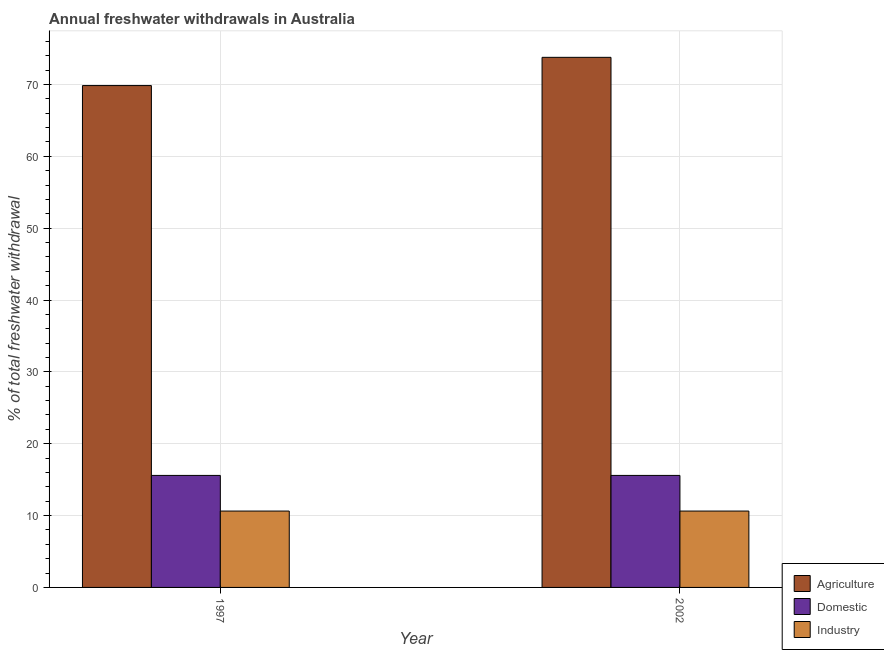How many groups of bars are there?
Provide a succinct answer. 2. Are the number of bars per tick equal to the number of legend labels?
Provide a succinct answer. Yes. Are the number of bars on each tick of the X-axis equal?
Offer a terse response. Yes. How many bars are there on the 1st tick from the left?
Provide a succinct answer. 3. How many bars are there on the 2nd tick from the right?
Your response must be concise. 3. In how many cases, is the number of bars for a given year not equal to the number of legend labels?
Ensure brevity in your answer.  0. What is the percentage of freshwater withdrawal for domestic purposes in 1997?
Ensure brevity in your answer.  15.59. Across all years, what is the maximum percentage of freshwater withdrawal for agriculture?
Make the answer very short. 73.78. Across all years, what is the minimum percentage of freshwater withdrawal for agriculture?
Your answer should be very brief. 69.85. In which year was the percentage of freshwater withdrawal for domestic purposes minimum?
Your answer should be compact. 1997. What is the total percentage of freshwater withdrawal for industry in the graph?
Your response must be concise. 21.26. What is the difference between the percentage of freshwater withdrawal for agriculture in 1997 and that in 2002?
Provide a succinct answer. -3.93. What is the difference between the percentage of freshwater withdrawal for domestic purposes in 1997 and the percentage of freshwater withdrawal for industry in 2002?
Keep it short and to the point. 0. What is the average percentage of freshwater withdrawal for industry per year?
Make the answer very short. 10.63. In the year 2002, what is the difference between the percentage of freshwater withdrawal for domestic purposes and percentage of freshwater withdrawal for industry?
Offer a very short reply. 0. What does the 1st bar from the left in 1997 represents?
Offer a terse response. Agriculture. What does the 3rd bar from the right in 1997 represents?
Offer a terse response. Agriculture. How many years are there in the graph?
Offer a very short reply. 2. What is the difference between two consecutive major ticks on the Y-axis?
Your answer should be very brief. 10. Does the graph contain grids?
Make the answer very short. Yes. Where does the legend appear in the graph?
Offer a very short reply. Bottom right. How many legend labels are there?
Make the answer very short. 3. How are the legend labels stacked?
Offer a terse response. Vertical. What is the title of the graph?
Offer a terse response. Annual freshwater withdrawals in Australia. Does "Ages 20-50" appear as one of the legend labels in the graph?
Ensure brevity in your answer.  No. What is the label or title of the X-axis?
Ensure brevity in your answer.  Year. What is the label or title of the Y-axis?
Provide a short and direct response. % of total freshwater withdrawal. What is the % of total freshwater withdrawal in Agriculture in 1997?
Your answer should be very brief. 69.85. What is the % of total freshwater withdrawal in Domestic in 1997?
Make the answer very short. 15.59. What is the % of total freshwater withdrawal in Industry in 1997?
Your response must be concise. 10.63. What is the % of total freshwater withdrawal of Agriculture in 2002?
Provide a succinct answer. 73.78. What is the % of total freshwater withdrawal in Domestic in 2002?
Give a very brief answer. 15.59. What is the % of total freshwater withdrawal of Industry in 2002?
Keep it short and to the point. 10.63. Across all years, what is the maximum % of total freshwater withdrawal in Agriculture?
Keep it short and to the point. 73.78. Across all years, what is the maximum % of total freshwater withdrawal in Domestic?
Your answer should be compact. 15.59. Across all years, what is the maximum % of total freshwater withdrawal in Industry?
Your answer should be very brief. 10.63. Across all years, what is the minimum % of total freshwater withdrawal in Agriculture?
Offer a very short reply. 69.85. Across all years, what is the minimum % of total freshwater withdrawal of Domestic?
Ensure brevity in your answer.  15.59. Across all years, what is the minimum % of total freshwater withdrawal in Industry?
Your response must be concise. 10.63. What is the total % of total freshwater withdrawal of Agriculture in the graph?
Ensure brevity in your answer.  143.63. What is the total % of total freshwater withdrawal of Domestic in the graph?
Provide a short and direct response. 31.18. What is the total % of total freshwater withdrawal in Industry in the graph?
Your answer should be compact. 21.26. What is the difference between the % of total freshwater withdrawal of Agriculture in 1997 and that in 2002?
Your answer should be very brief. -3.93. What is the difference between the % of total freshwater withdrawal in Agriculture in 1997 and the % of total freshwater withdrawal in Domestic in 2002?
Make the answer very short. 54.26. What is the difference between the % of total freshwater withdrawal of Agriculture in 1997 and the % of total freshwater withdrawal of Industry in 2002?
Your answer should be very brief. 59.22. What is the difference between the % of total freshwater withdrawal of Domestic in 1997 and the % of total freshwater withdrawal of Industry in 2002?
Provide a succinct answer. 4.96. What is the average % of total freshwater withdrawal of Agriculture per year?
Make the answer very short. 71.81. What is the average % of total freshwater withdrawal in Domestic per year?
Keep it short and to the point. 15.59. What is the average % of total freshwater withdrawal in Industry per year?
Provide a succinct answer. 10.63. In the year 1997, what is the difference between the % of total freshwater withdrawal in Agriculture and % of total freshwater withdrawal in Domestic?
Keep it short and to the point. 54.26. In the year 1997, what is the difference between the % of total freshwater withdrawal of Agriculture and % of total freshwater withdrawal of Industry?
Your answer should be very brief. 59.22. In the year 1997, what is the difference between the % of total freshwater withdrawal in Domestic and % of total freshwater withdrawal in Industry?
Give a very brief answer. 4.96. In the year 2002, what is the difference between the % of total freshwater withdrawal in Agriculture and % of total freshwater withdrawal in Domestic?
Your answer should be very brief. 58.19. In the year 2002, what is the difference between the % of total freshwater withdrawal of Agriculture and % of total freshwater withdrawal of Industry?
Give a very brief answer. 63.15. In the year 2002, what is the difference between the % of total freshwater withdrawal of Domestic and % of total freshwater withdrawal of Industry?
Your response must be concise. 4.96. What is the ratio of the % of total freshwater withdrawal in Agriculture in 1997 to that in 2002?
Keep it short and to the point. 0.95. What is the ratio of the % of total freshwater withdrawal of Industry in 1997 to that in 2002?
Your response must be concise. 1. What is the difference between the highest and the second highest % of total freshwater withdrawal in Agriculture?
Your response must be concise. 3.93. What is the difference between the highest and the lowest % of total freshwater withdrawal in Agriculture?
Your response must be concise. 3.93. What is the difference between the highest and the lowest % of total freshwater withdrawal in Domestic?
Your answer should be compact. 0. 